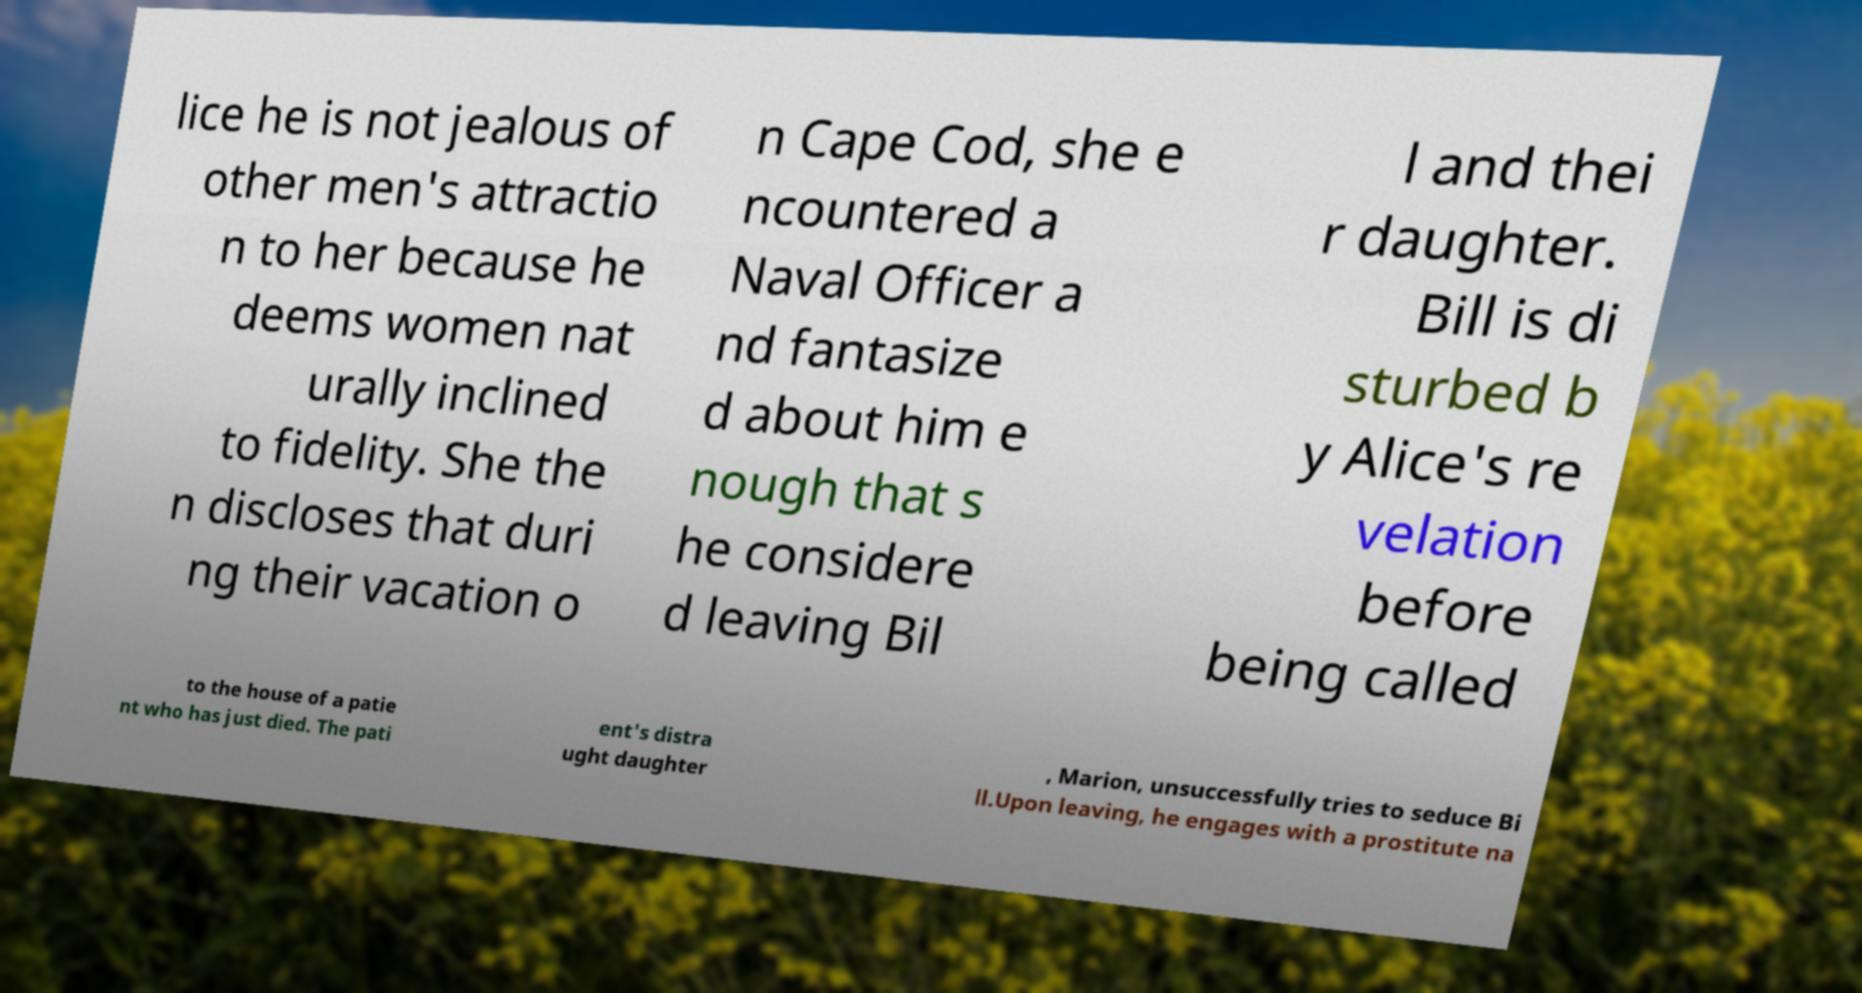For documentation purposes, I need the text within this image transcribed. Could you provide that? lice he is not jealous of other men's attractio n to her because he deems women nat urally inclined to fidelity. She the n discloses that duri ng their vacation o n Cape Cod, she e ncountered a Naval Officer a nd fantasize d about him e nough that s he considere d leaving Bil l and thei r daughter. Bill is di sturbed b y Alice's re velation before being called to the house of a patie nt who has just died. The pati ent's distra ught daughter , Marion, unsuccessfully tries to seduce Bi ll.Upon leaving, he engages with a prostitute na 